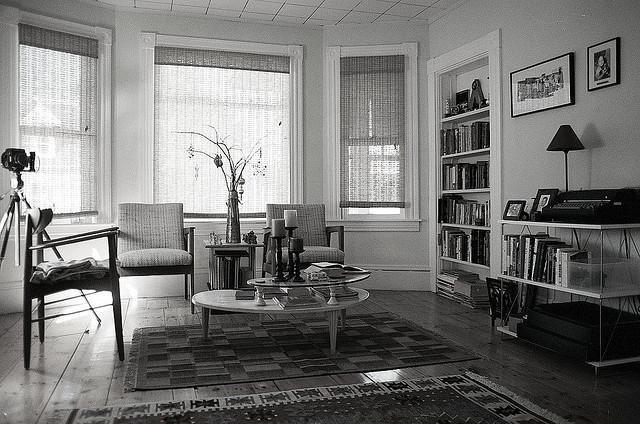What is the camera on the left setup on?

Choices:
A) selfie stick
B) table
C) tripod
D) mixer tripod 